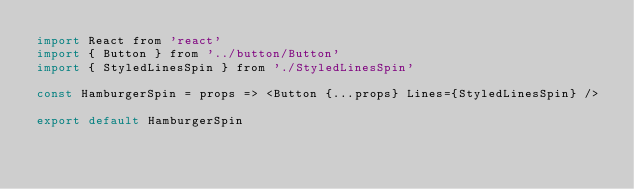Convert code to text. <code><loc_0><loc_0><loc_500><loc_500><_JavaScript_>import React from 'react'
import { Button } from '../button/Button'
import { StyledLinesSpin } from './StyledLinesSpin'

const HamburgerSpin = props => <Button {...props} Lines={StyledLinesSpin} />

export default HamburgerSpin
</code> 